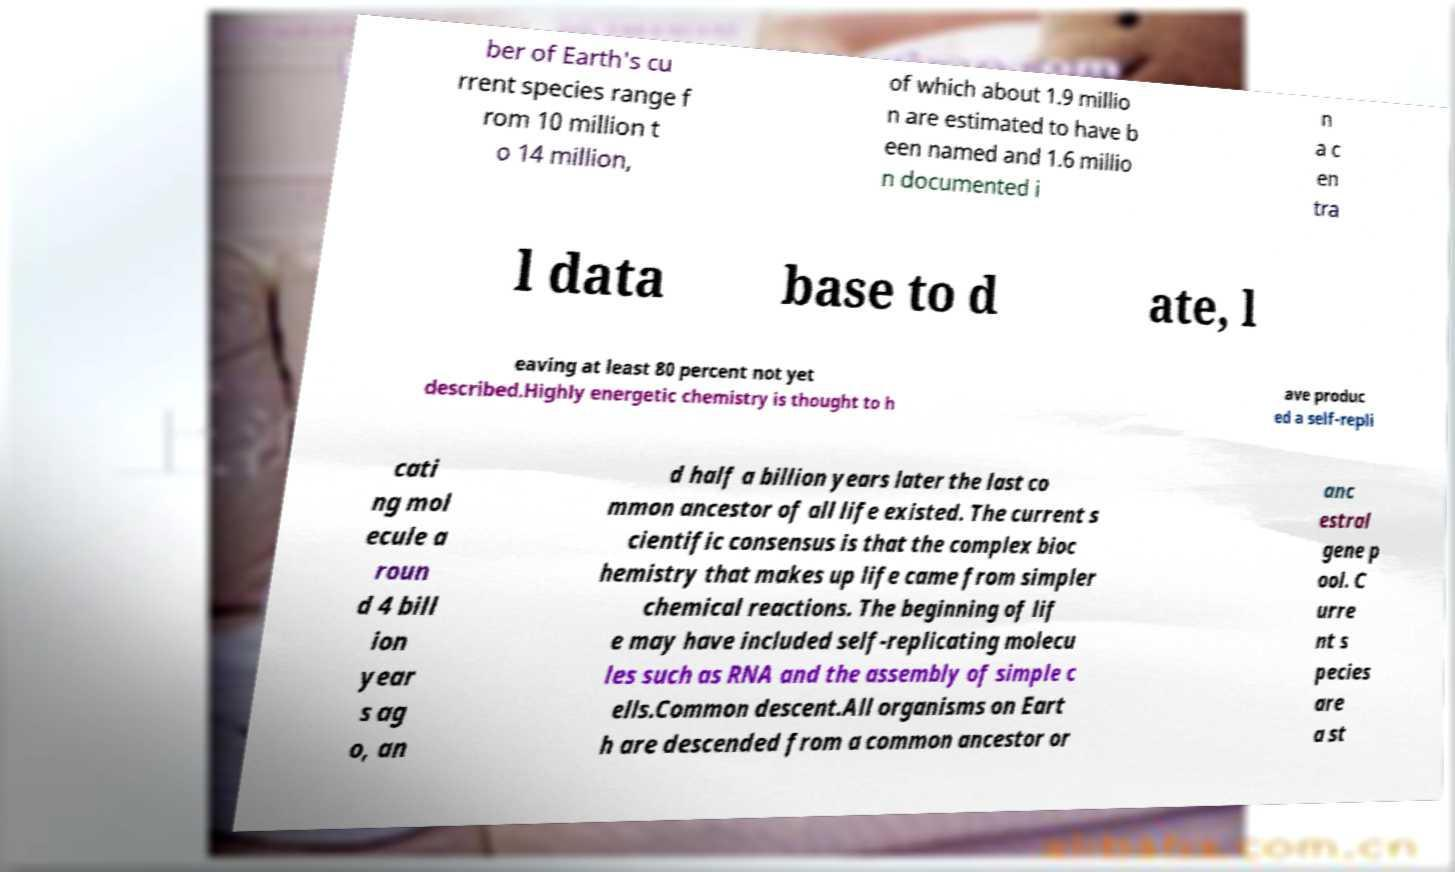Can you read and provide the text displayed in the image?This photo seems to have some interesting text. Can you extract and type it out for me? ber of Earth's cu rrent species range f rom 10 million t o 14 million, of which about 1.9 millio n are estimated to have b een named and 1.6 millio n documented i n a c en tra l data base to d ate, l eaving at least 80 percent not yet described.Highly energetic chemistry is thought to h ave produc ed a self-repli cati ng mol ecule a roun d 4 bill ion year s ag o, an d half a billion years later the last co mmon ancestor of all life existed. The current s cientific consensus is that the complex bioc hemistry that makes up life came from simpler chemical reactions. The beginning of lif e may have included self-replicating molecu les such as RNA and the assembly of simple c ells.Common descent.All organisms on Eart h are descended from a common ancestor or anc estral gene p ool. C urre nt s pecies are a st 